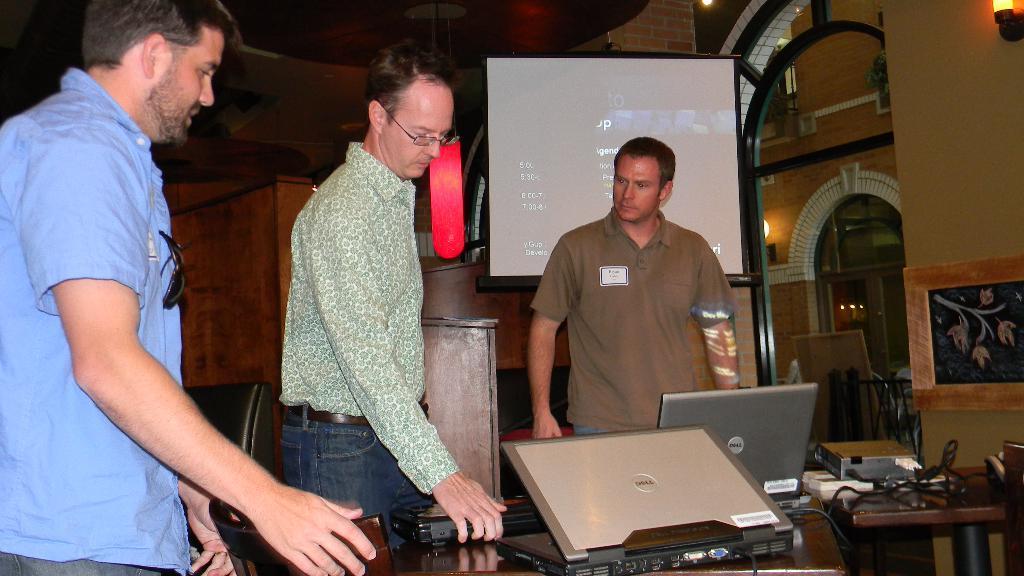Describe this image in one or two sentences. In this picture there are two people at the left side of the image and there is a person who is at the center of the image and there is a projector screen behind him, and there is a table in front of them, where there are papers laptop are kept and there is a portrait at the right side of the image. 